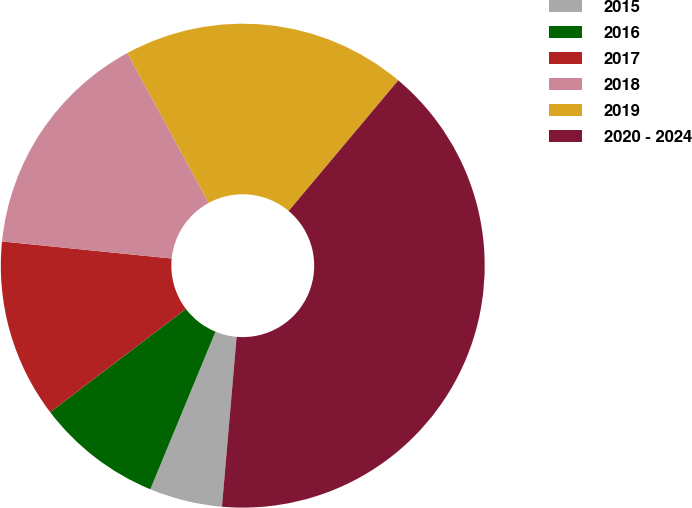Convert chart. <chart><loc_0><loc_0><loc_500><loc_500><pie_chart><fcel>2015<fcel>2016<fcel>2017<fcel>2018<fcel>2019<fcel>2020 - 2024<nl><fcel>4.87%<fcel>8.41%<fcel>11.95%<fcel>15.49%<fcel>19.03%<fcel>40.26%<nl></chart> 